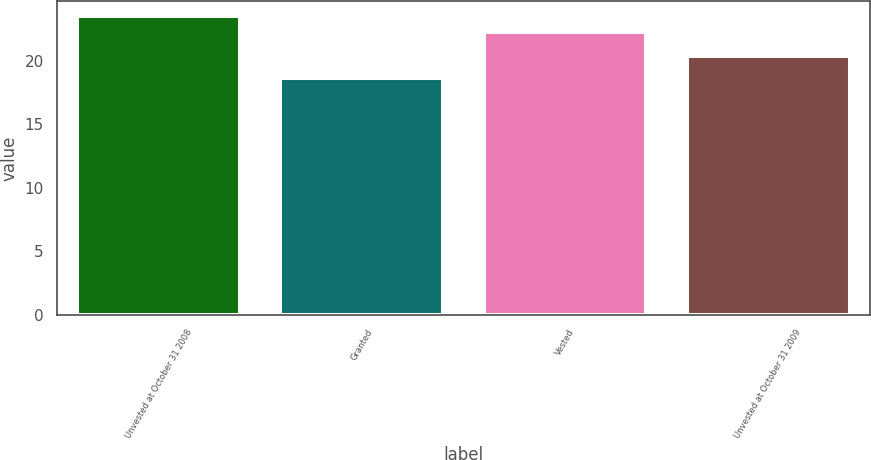Convert chart to OTSL. <chart><loc_0><loc_0><loc_500><loc_500><bar_chart><fcel>Unvested at October 31 2008<fcel>Granted<fcel>Vested<fcel>Unvested at October 31 2009<nl><fcel>23.52<fcel>18.63<fcel>22.25<fcel>20.4<nl></chart> 